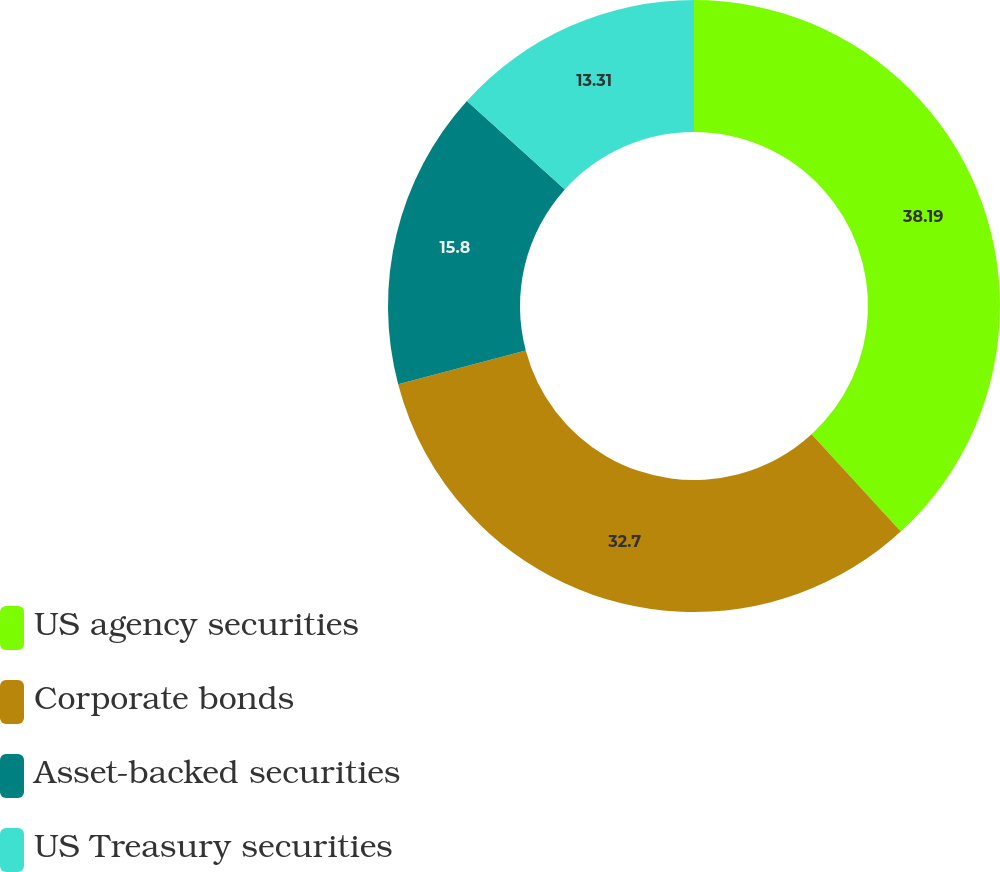Convert chart. <chart><loc_0><loc_0><loc_500><loc_500><pie_chart><fcel>US agency securities<fcel>Corporate bonds<fcel>Asset-backed securities<fcel>US Treasury securities<nl><fcel>38.19%<fcel>32.7%<fcel>15.8%<fcel>13.31%<nl></chart> 